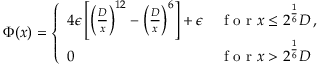Convert formula to latex. <formula><loc_0><loc_0><loc_500><loc_500>\Phi ( x ) = \left \{ \begin{array} { l l } { 4 \epsilon \left [ \left ( \frac { D } { x } \right ) ^ { 1 2 } - \left ( \frac { D } { x } \right ) ^ { 6 } \right ] + \epsilon } & { f o r x \leq 2 ^ { \frac { 1 } { 6 } } D \, , } \\ { 0 } & { f o r x > 2 ^ { \frac { 1 } { 6 } } D } \end{array}</formula> 